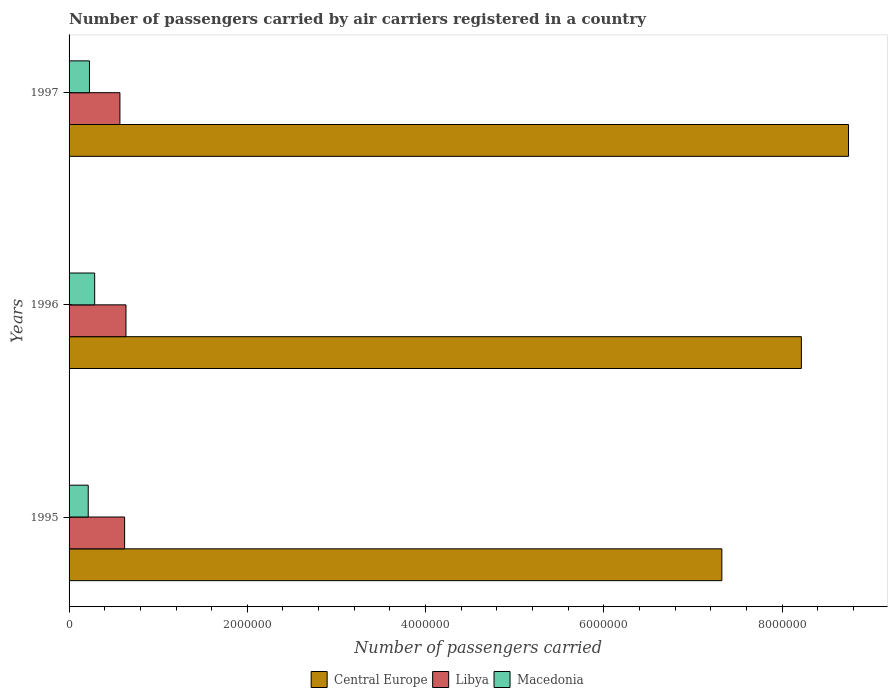Are the number of bars per tick equal to the number of legend labels?
Offer a very short reply. Yes. Are the number of bars on each tick of the Y-axis equal?
Ensure brevity in your answer.  Yes. How many bars are there on the 1st tick from the top?
Keep it short and to the point. 3. How many bars are there on the 2nd tick from the bottom?
Offer a terse response. 3. What is the label of the 2nd group of bars from the top?
Keep it short and to the point. 1996. What is the number of passengers carried by air carriers in Libya in 1995?
Provide a succinct answer. 6.23e+05. Across all years, what is the maximum number of passengers carried by air carriers in Libya?
Give a very brief answer. 6.39e+05. Across all years, what is the minimum number of passengers carried by air carriers in Central Europe?
Keep it short and to the point. 7.32e+06. In which year was the number of passengers carried by air carriers in Libya minimum?
Provide a succinct answer. 1997. What is the total number of passengers carried by air carriers in Libya in the graph?
Your answer should be very brief. 1.83e+06. What is the difference between the number of passengers carried by air carriers in Macedonia in 1995 and that in 1997?
Your answer should be very brief. -1.39e+04. What is the difference between the number of passengers carried by air carriers in Central Europe in 1997 and the number of passengers carried by air carriers in Macedonia in 1995?
Offer a very short reply. 8.53e+06. What is the average number of passengers carried by air carriers in Libya per year?
Provide a succinct answer. 6.11e+05. In the year 1996, what is the difference between the number of passengers carried by air carriers in Macedonia and number of passengers carried by air carriers in Central Europe?
Ensure brevity in your answer.  -7.93e+06. What is the ratio of the number of passengers carried by air carriers in Libya in 1996 to that in 1997?
Provide a short and direct response. 1.12. Is the difference between the number of passengers carried by air carriers in Macedonia in 1995 and 1997 greater than the difference between the number of passengers carried by air carriers in Central Europe in 1995 and 1997?
Give a very brief answer. Yes. What is the difference between the highest and the second highest number of passengers carried by air carriers in Libya?
Give a very brief answer. 1.54e+04. What is the difference between the highest and the lowest number of passengers carried by air carriers in Central Europe?
Your answer should be compact. 1.42e+06. What does the 2nd bar from the top in 1996 represents?
Offer a terse response. Libya. What does the 1st bar from the bottom in 1997 represents?
Your answer should be compact. Central Europe. Is it the case that in every year, the sum of the number of passengers carried by air carriers in Libya and number of passengers carried by air carriers in Macedonia is greater than the number of passengers carried by air carriers in Central Europe?
Give a very brief answer. No. How many bars are there?
Ensure brevity in your answer.  9. Are the values on the major ticks of X-axis written in scientific E-notation?
Offer a terse response. No. Does the graph contain any zero values?
Your answer should be very brief. No. Does the graph contain grids?
Ensure brevity in your answer.  No. What is the title of the graph?
Your response must be concise. Number of passengers carried by air carriers registered in a country. What is the label or title of the X-axis?
Offer a terse response. Number of passengers carried. What is the Number of passengers carried in Central Europe in 1995?
Provide a short and direct response. 7.32e+06. What is the Number of passengers carried in Libya in 1995?
Offer a very short reply. 6.23e+05. What is the Number of passengers carried of Macedonia in 1995?
Provide a succinct answer. 2.15e+05. What is the Number of passengers carried in Central Europe in 1996?
Offer a very short reply. 8.22e+06. What is the Number of passengers carried of Libya in 1996?
Offer a terse response. 6.39e+05. What is the Number of passengers carried of Macedonia in 1996?
Provide a short and direct response. 2.87e+05. What is the Number of passengers carried of Central Europe in 1997?
Ensure brevity in your answer.  8.75e+06. What is the Number of passengers carried of Libya in 1997?
Provide a short and direct response. 5.71e+05. What is the Number of passengers carried in Macedonia in 1997?
Offer a terse response. 2.29e+05. Across all years, what is the maximum Number of passengers carried in Central Europe?
Your answer should be compact. 8.75e+06. Across all years, what is the maximum Number of passengers carried of Libya?
Offer a terse response. 6.39e+05. Across all years, what is the maximum Number of passengers carried of Macedonia?
Provide a succinct answer. 2.87e+05. Across all years, what is the minimum Number of passengers carried in Central Europe?
Provide a succinct answer. 7.32e+06. Across all years, what is the minimum Number of passengers carried of Libya?
Your response must be concise. 5.71e+05. Across all years, what is the minimum Number of passengers carried of Macedonia?
Provide a succinct answer. 2.15e+05. What is the total Number of passengers carried of Central Europe in the graph?
Your response must be concise. 2.43e+07. What is the total Number of passengers carried in Libya in the graph?
Offer a terse response. 1.83e+06. What is the total Number of passengers carried in Macedonia in the graph?
Provide a succinct answer. 7.31e+05. What is the difference between the Number of passengers carried of Central Europe in 1995 and that in 1996?
Provide a succinct answer. -8.92e+05. What is the difference between the Number of passengers carried of Libya in 1995 and that in 1996?
Your answer should be very brief. -1.54e+04. What is the difference between the Number of passengers carried of Macedonia in 1995 and that in 1996?
Make the answer very short. -7.23e+04. What is the difference between the Number of passengers carried of Central Europe in 1995 and that in 1997?
Your response must be concise. -1.42e+06. What is the difference between the Number of passengers carried of Libya in 1995 and that in 1997?
Your response must be concise. 5.26e+04. What is the difference between the Number of passengers carried in Macedonia in 1995 and that in 1997?
Keep it short and to the point. -1.39e+04. What is the difference between the Number of passengers carried of Central Europe in 1996 and that in 1997?
Your answer should be compact. -5.29e+05. What is the difference between the Number of passengers carried in Libya in 1996 and that in 1997?
Provide a succinct answer. 6.80e+04. What is the difference between the Number of passengers carried in Macedonia in 1996 and that in 1997?
Ensure brevity in your answer.  5.84e+04. What is the difference between the Number of passengers carried in Central Europe in 1995 and the Number of passengers carried in Libya in 1996?
Offer a terse response. 6.69e+06. What is the difference between the Number of passengers carried in Central Europe in 1995 and the Number of passengers carried in Macedonia in 1996?
Make the answer very short. 7.04e+06. What is the difference between the Number of passengers carried in Libya in 1995 and the Number of passengers carried in Macedonia in 1996?
Offer a very short reply. 3.36e+05. What is the difference between the Number of passengers carried in Central Europe in 1995 and the Number of passengers carried in Libya in 1997?
Provide a succinct answer. 6.75e+06. What is the difference between the Number of passengers carried in Central Europe in 1995 and the Number of passengers carried in Macedonia in 1997?
Provide a succinct answer. 7.10e+06. What is the difference between the Number of passengers carried of Libya in 1995 and the Number of passengers carried of Macedonia in 1997?
Keep it short and to the point. 3.94e+05. What is the difference between the Number of passengers carried in Central Europe in 1996 and the Number of passengers carried in Libya in 1997?
Make the answer very short. 7.65e+06. What is the difference between the Number of passengers carried in Central Europe in 1996 and the Number of passengers carried in Macedonia in 1997?
Keep it short and to the point. 7.99e+06. What is the difference between the Number of passengers carried in Libya in 1996 and the Number of passengers carried in Macedonia in 1997?
Make the answer very short. 4.10e+05. What is the average Number of passengers carried in Central Europe per year?
Keep it short and to the point. 8.10e+06. What is the average Number of passengers carried in Libya per year?
Provide a succinct answer. 6.11e+05. What is the average Number of passengers carried of Macedonia per year?
Make the answer very short. 2.44e+05. In the year 1995, what is the difference between the Number of passengers carried of Central Europe and Number of passengers carried of Libya?
Your answer should be very brief. 6.70e+06. In the year 1995, what is the difference between the Number of passengers carried of Central Europe and Number of passengers carried of Macedonia?
Give a very brief answer. 7.11e+06. In the year 1995, what is the difference between the Number of passengers carried in Libya and Number of passengers carried in Macedonia?
Your response must be concise. 4.08e+05. In the year 1996, what is the difference between the Number of passengers carried in Central Europe and Number of passengers carried in Libya?
Keep it short and to the point. 7.58e+06. In the year 1996, what is the difference between the Number of passengers carried in Central Europe and Number of passengers carried in Macedonia?
Keep it short and to the point. 7.93e+06. In the year 1996, what is the difference between the Number of passengers carried of Libya and Number of passengers carried of Macedonia?
Your answer should be compact. 3.51e+05. In the year 1997, what is the difference between the Number of passengers carried in Central Europe and Number of passengers carried in Libya?
Your answer should be very brief. 8.17e+06. In the year 1997, what is the difference between the Number of passengers carried in Central Europe and Number of passengers carried in Macedonia?
Give a very brief answer. 8.52e+06. In the year 1997, what is the difference between the Number of passengers carried in Libya and Number of passengers carried in Macedonia?
Your response must be concise. 3.42e+05. What is the ratio of the Number of passengers carried of Central Europe in 1995 to that in 1996?
Your answer should be compact. 0.89. What is the ratio of the Number of passengers carried of Libya in 1995 to that in 1996?
Your answer should be compact. 0.98. What is the ratio of the Number of passengers carried of Macedonia in 1995 to that in 1996?
Your answer should be very brief. 0.75. What is the ratio of the Number of passengers carried of Central Europe in 1995 to that in 1997?
Keep it short and to the point. 0.84. What is the ratio of the Number of passengers carried of Libya in 1995 to that in 1997?
Your response must be concise. 1.09. What is the ratio of the Number of passengers carried of Macedonia in 1995 to that in 1997?
Provide a short and direct response. 0.94. What is the ratio of the Number of passengers carried of Central Europe in 1996 to that in 1997?
Ensure brevity in your answer.  0.94. What is the ratio of the Number of passengers carried of Libya in 1996 to that in 1997?
Provide a short and direct response. 1.12. What is the ratio of the Number of passengers carried in Macedonia in 1996 to that in 1997?
Your answer should be compact. 1.26. What is the difference between the highest and the second highest Number of passengers carried in Central Europe?
Your answer should be compact. 5.29e+05. What is the difference between the highest and the second highest Number of passengers carried in Libya?
Provide a short and direct response. 1.54e+04. What is the difference between the highest and the second highest Number of passengers carried in Macedonia?
Your response must be concise. 5.84e+04. What is the difference between the highest and the lowest Number of passengers carried of Central Europe?
Your answer should be compact. 1.42e+06. What is the difference between the highest and the lowest Number of passengers carried of Libya?
Ensure brevity in your answer.  6.80e+04. What is the difference between the highest and the lowest Number of passengers carried in Macedonia?
Give a very brief answer. 7.23e+04. 